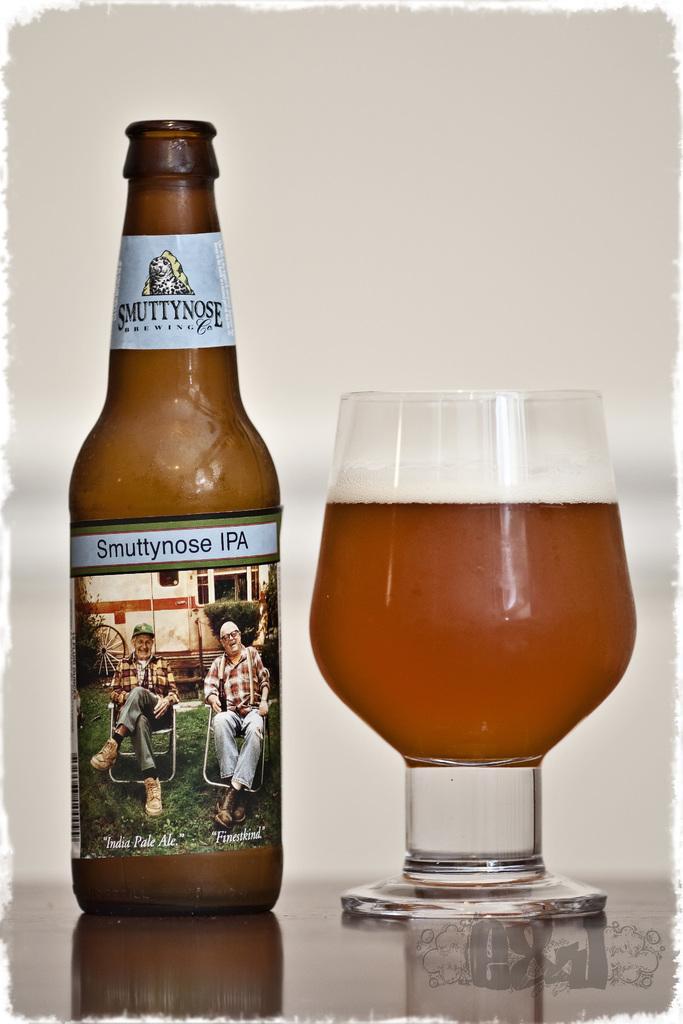How would you summarize this image in a sentence or two? In this image there is a wine bottle with a label and lid , and a glass of wine kept on a table, and at the back ground there is a wall. 